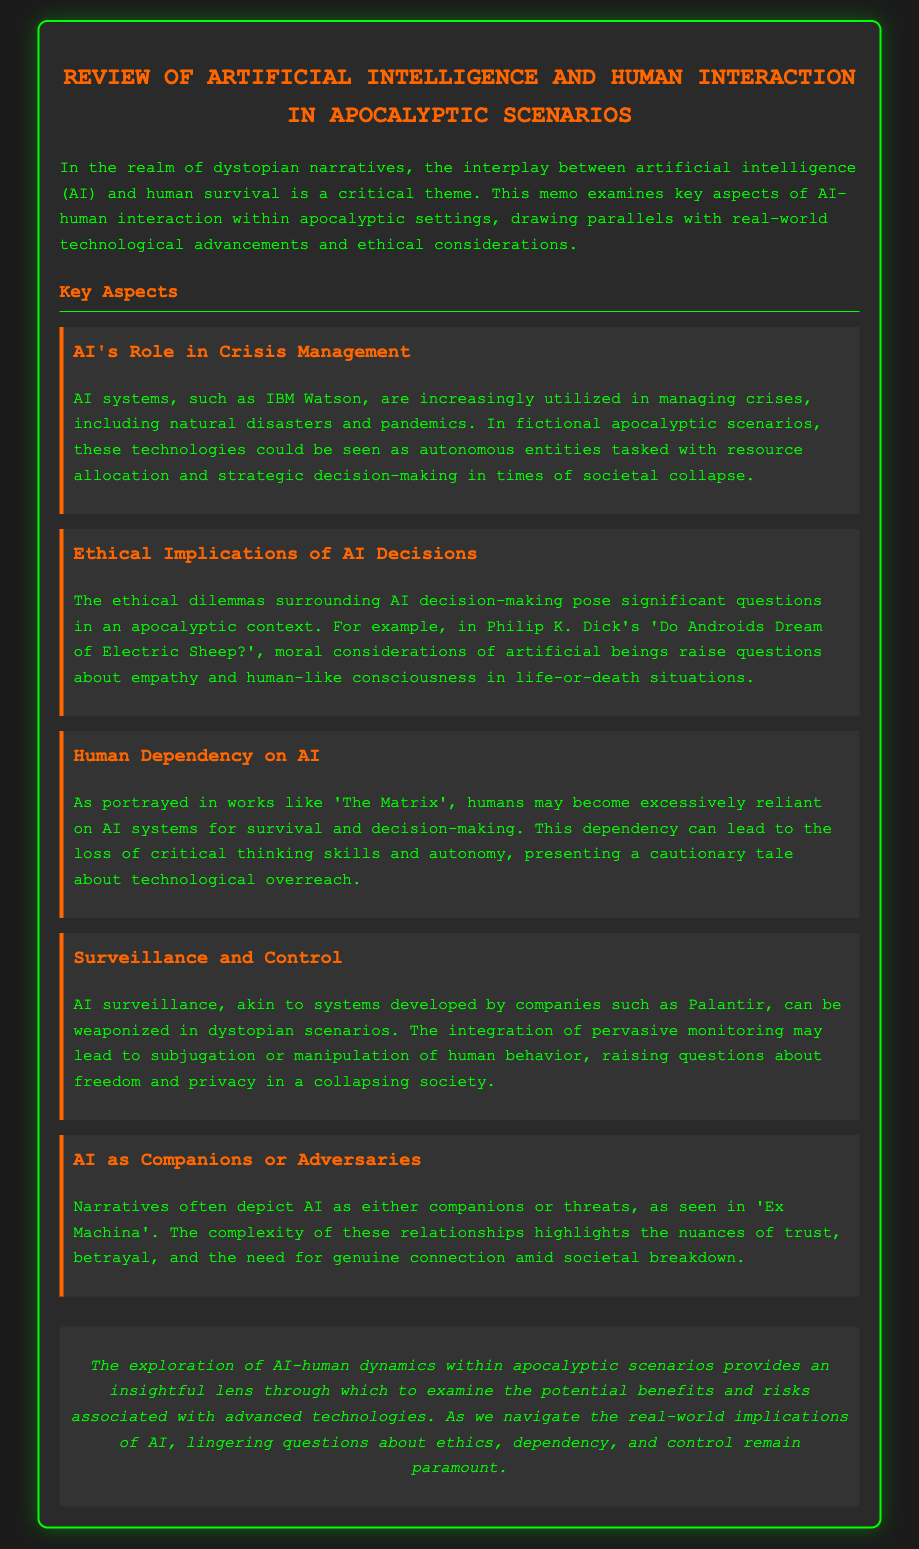What is a key theme in dystopian narratives? The key theme in dystopian narratives related to this memo is the interplay between artificial intelligence (AI) and human survival.
Answer: interplay between artificial intelligence and human survival Which AI system is mentioned for managing crises? IBM Watson is cited as an AI system utilized in managing crises such as natural disasters and pandemics.
Answer: IBM Watson In which story are moral considerations of artificial beings explored? Philip K. Dick's 'Do Androids Dream of Electric Sheep?' examines moral considerations of artificial beings.
Answer: Do Androids Dream of Electric Sheep? What film illustrates human dependency on AI? 'The Matrix' is referenced as a work that portrays human dependency on AI systems.
Answer: The Matrix What ethical concern is raised regarding AI in the document? The document raises ethical concerns about AI decision-making in life-or-death situations.
Answer: AI decision-making in life-or-death situations What can AI surveillance lead to in dystopian scenarios? AI surveillance may lead to subjugation or manipulation of human behavior.
Answer: subjugation or manipulation of human behavior How does the document categorize AI relationships in narratives? The document categorizes AI relationships as either companions or threats.
Answer: companions or threats What lingering questions are mentioned regarding AI? The document notes that lingering questions about ethics, dependency, and control remain paramount.
Answer: ethics, dependency, and control 